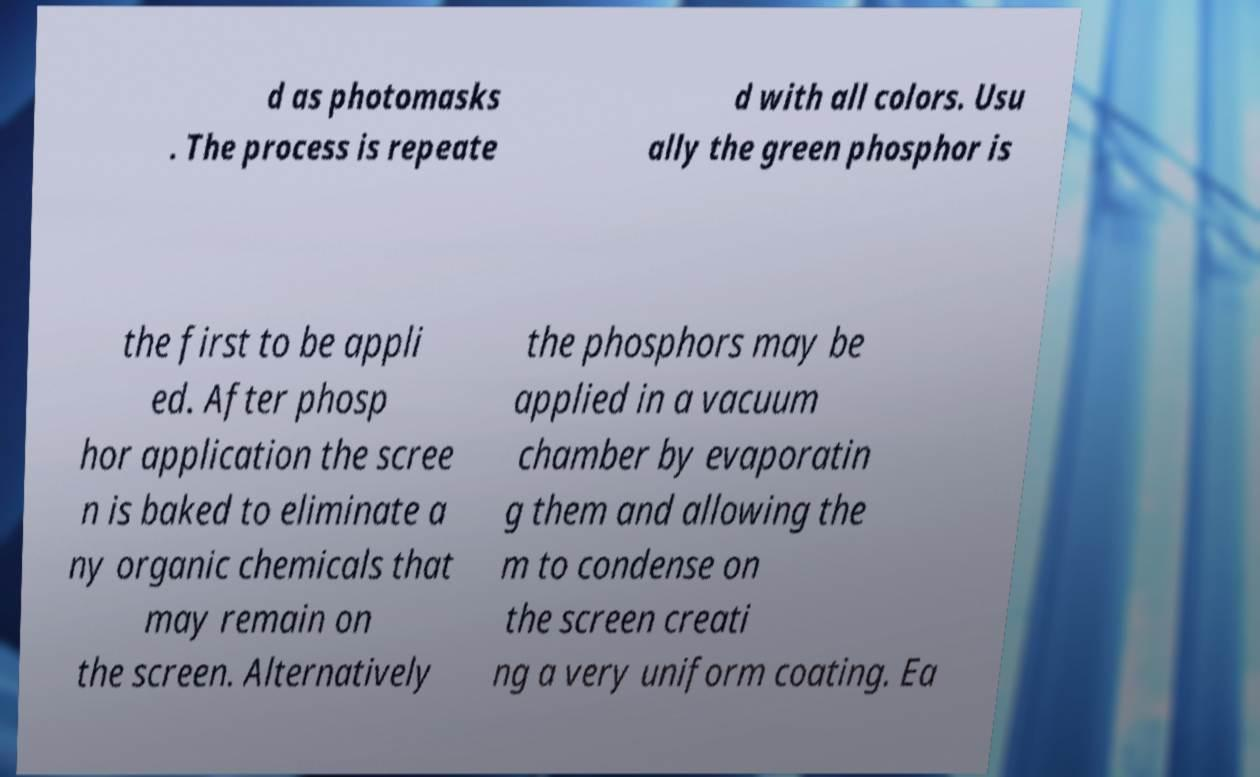Please identify and transcribe the text found in this image. d as photomasks . The process is repeate d with all colors. Usu ally the green phosphor is the first to be appli ed. After phosp hor application the scree n is baked to eliminate a ny organic chemicals that may remain on the screen. Alternatively the phosphors may be applied in a vacuum chamber by evaporatin g them and allowing the m to condense on the screen creati ng a very uniform coating. Ea 